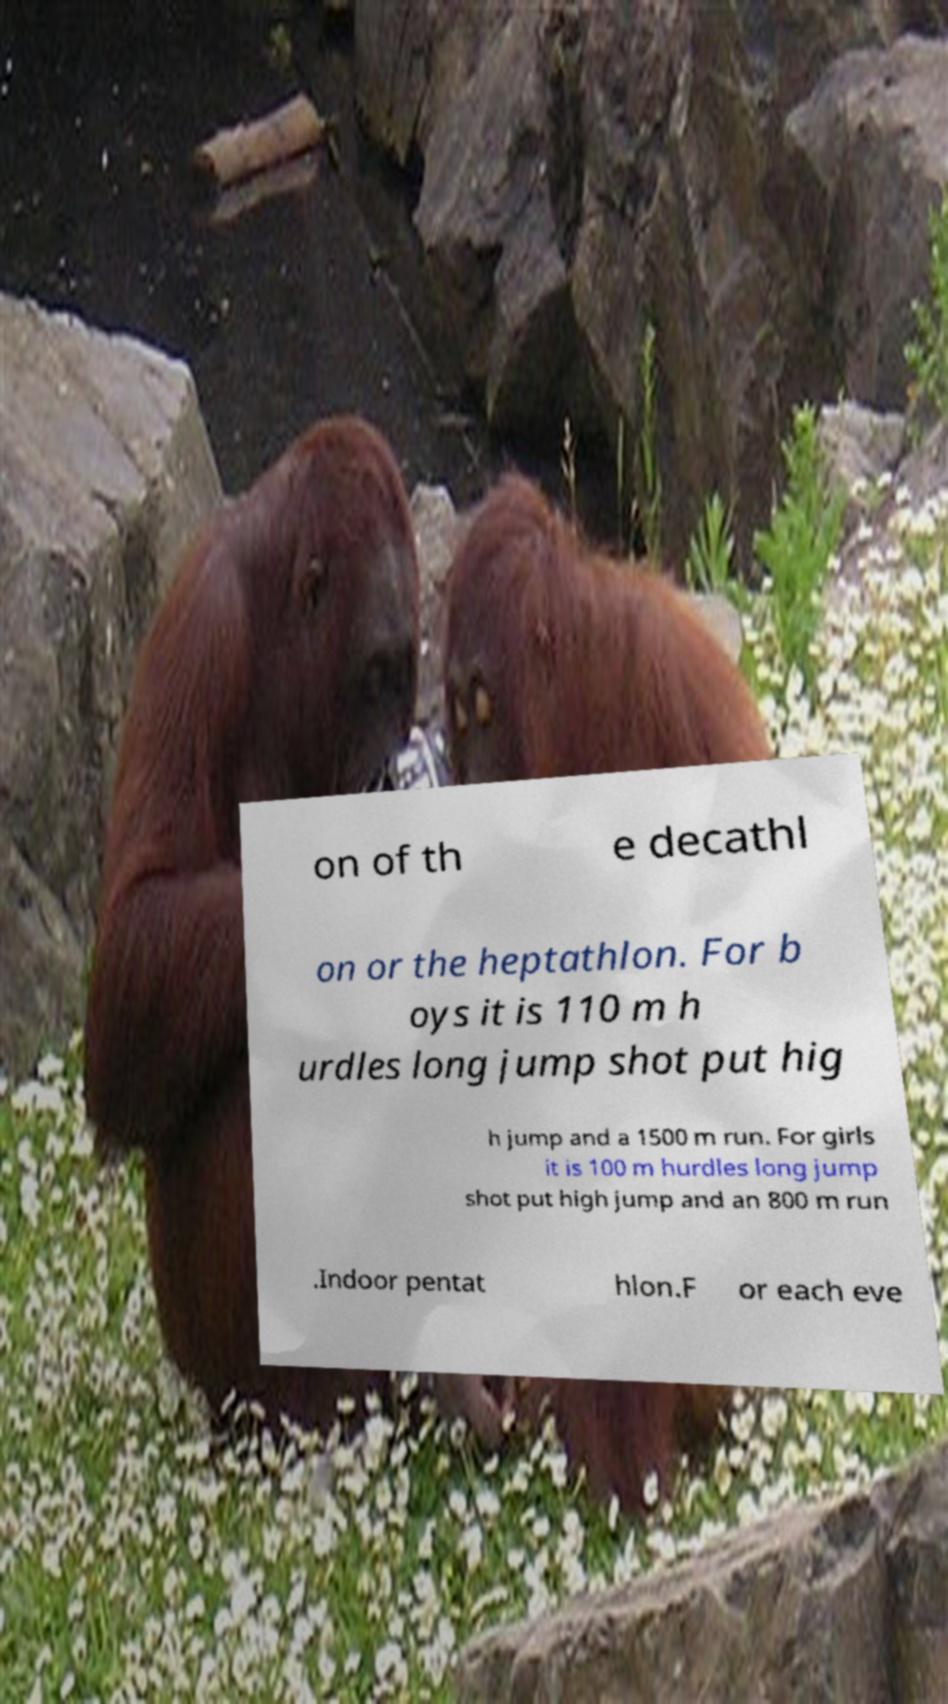There's text embedded in this image that I need extracted. Can you transcribe it verbatim? on of th e decathl on or the heptathlon. For b oys it is 110 m h urdles long jump shot put hig h jump and a 1500 m run. For girls it is 100 m hurdles long jump shot put high jump and an 800 m run .Indoor pentat hlon.F or each eve 